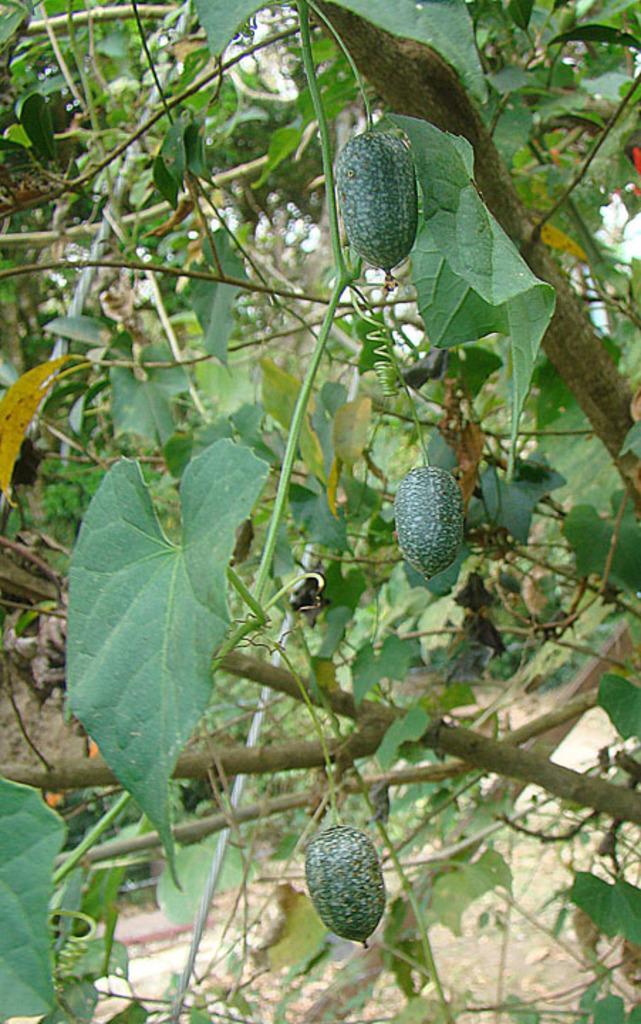Can you describe this image briefly? In this image there is a tree and we can see fruits to it. In the center there is a bug on the leaf. 